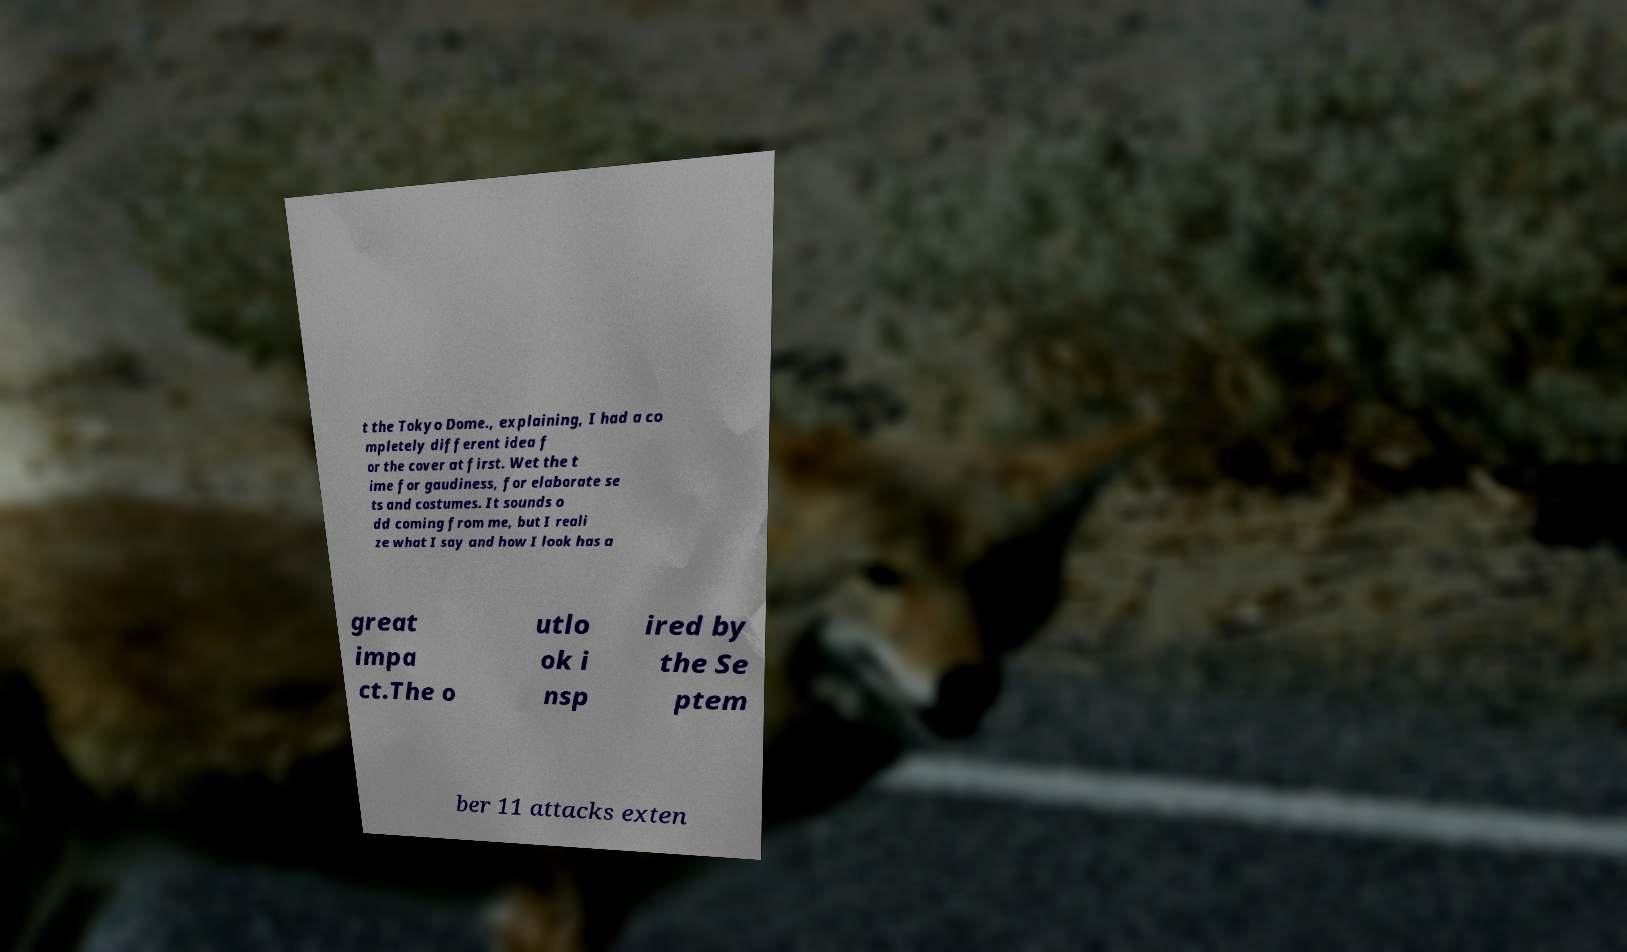Please read and relay the text visible in this image. What does it say? t the Tokyo Dome., explaining, I had a co mpletely different idea f or the cover at first. Wet the t ime for gaudiness, for elaborate se ts and costumes. It sounds o dd coming from me, but I reali ze what I say and how I look has a great impa ct.The o utlo ok i nsp ired by the Se ptem ber 11 attacks exten 